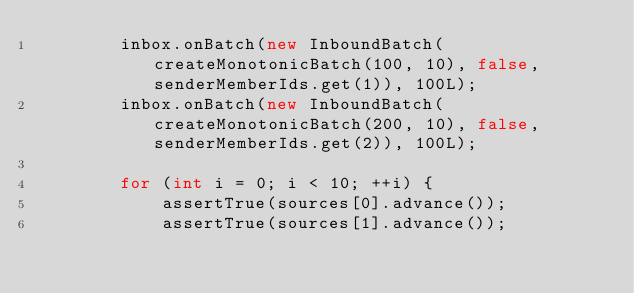Convert code to text. <code><loc_0><loc_0><loc_500><loc_500><_Java_>        inbox.onBatch(new InboundBatch(createMonotonicBatch(100, 10), false, senderMemberIds.get(1)), 100L);
        inbox.onBatch(new InboundBatch(createMonotonicBatch(200, 10), false, senderMemberIds.get(2)), 100L);

        for (int i = 0; i < 10; ++i) {
            assertTrue(sources[0].advance());
            assertTrue(sources[1].advance());</code> 